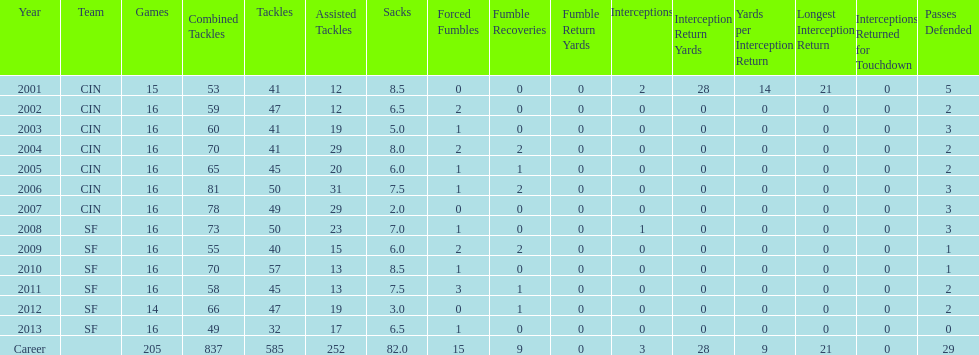How many sacks did this player have in his first five seasons? 34. 